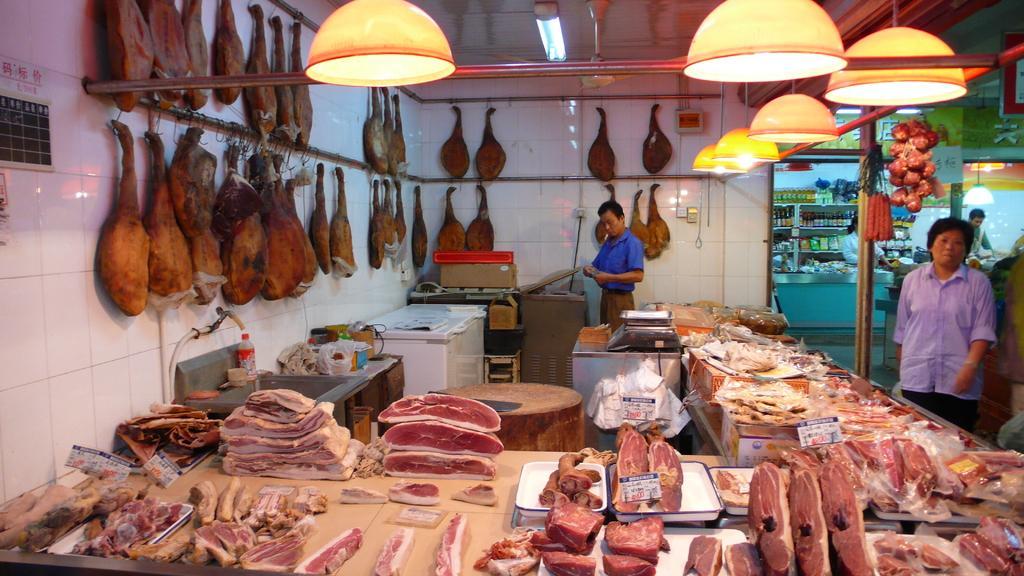How would you summarize this image in a sentence or two? In this image there is a meat in the table , food in the table and in the back ground there are lights , a man standing , another man standing , and there are some items in the rack, onions and poles. 